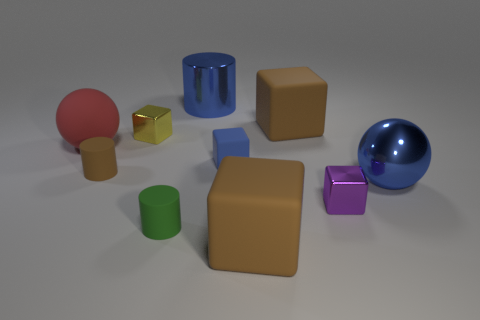Subtract all yellow cubes. How many cubes are left? 4 Subtract all blue cylinders. How many cylinders are left? 2 Subtract 1 cylinders. How many cylinders are left? 2 Subtract all cyan blocks. How many blue spheres are left? 1 Subtract all spheres. How many objects are left? 8 Subtract all gray balls. Subtract all blue cylinders. How many balls are left? 2 Subtract all gray metallic balls. Subtract all large cylinders. How many objects are left? 9 Add 3 large red matte objects. How many large red matte objects are left? 4 Add 6 tiny shiny things. How many tiny shiny things exist? 8 Subtract 0 yellow cylinders. How many objects are left? 10 